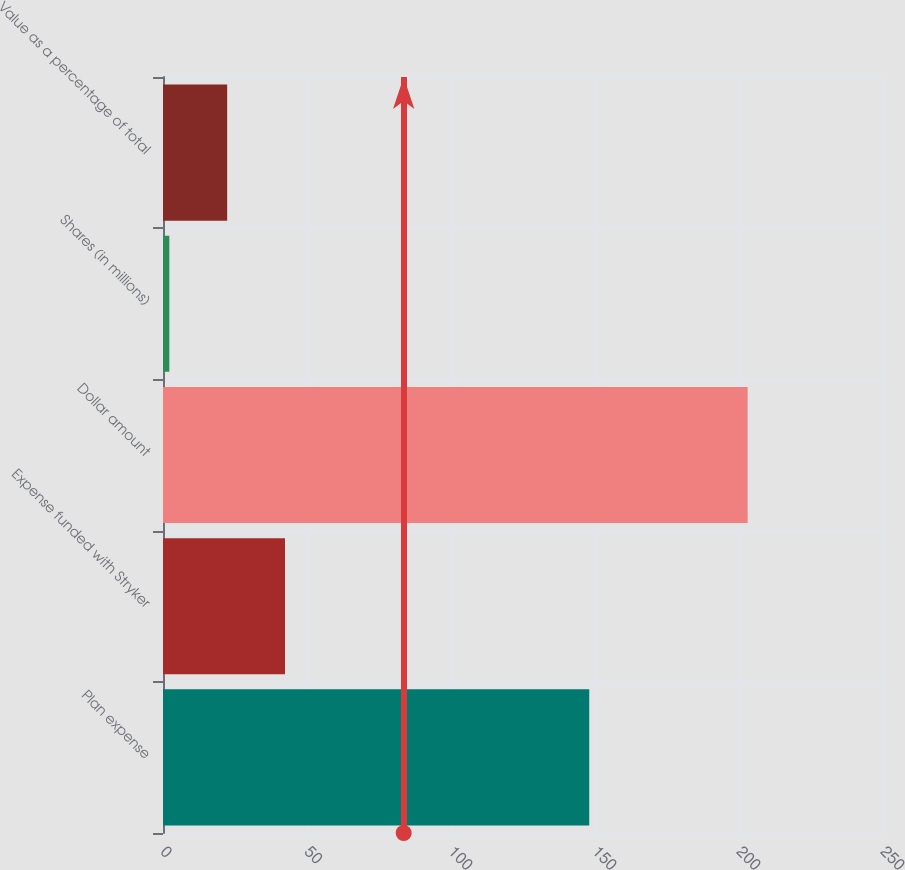Convert chart. <chart><loc_0><loc_0><loc_500><loc_500><bar_chart><fcel>Plan expense<fcel>Expense funded with Stryker<fcel>Dollar amount<fcel>Shares (in millions)<fcel>Value as a percentage of total<nl><fcel>148<fcel>42.36<fcel>203<fcel>2.2<fcel>22.28<nl></chart> 